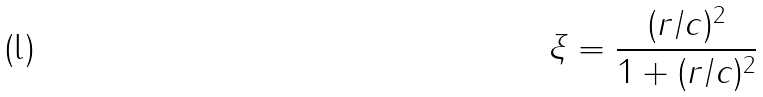Convert formula to latex. <formula><loc_0><loc_0><loc_500><loc_500>\xi = \frac { ( r / c ) ^ { 2 } } { 1 + ( r / c ) ^ { 2 } }</formula> 